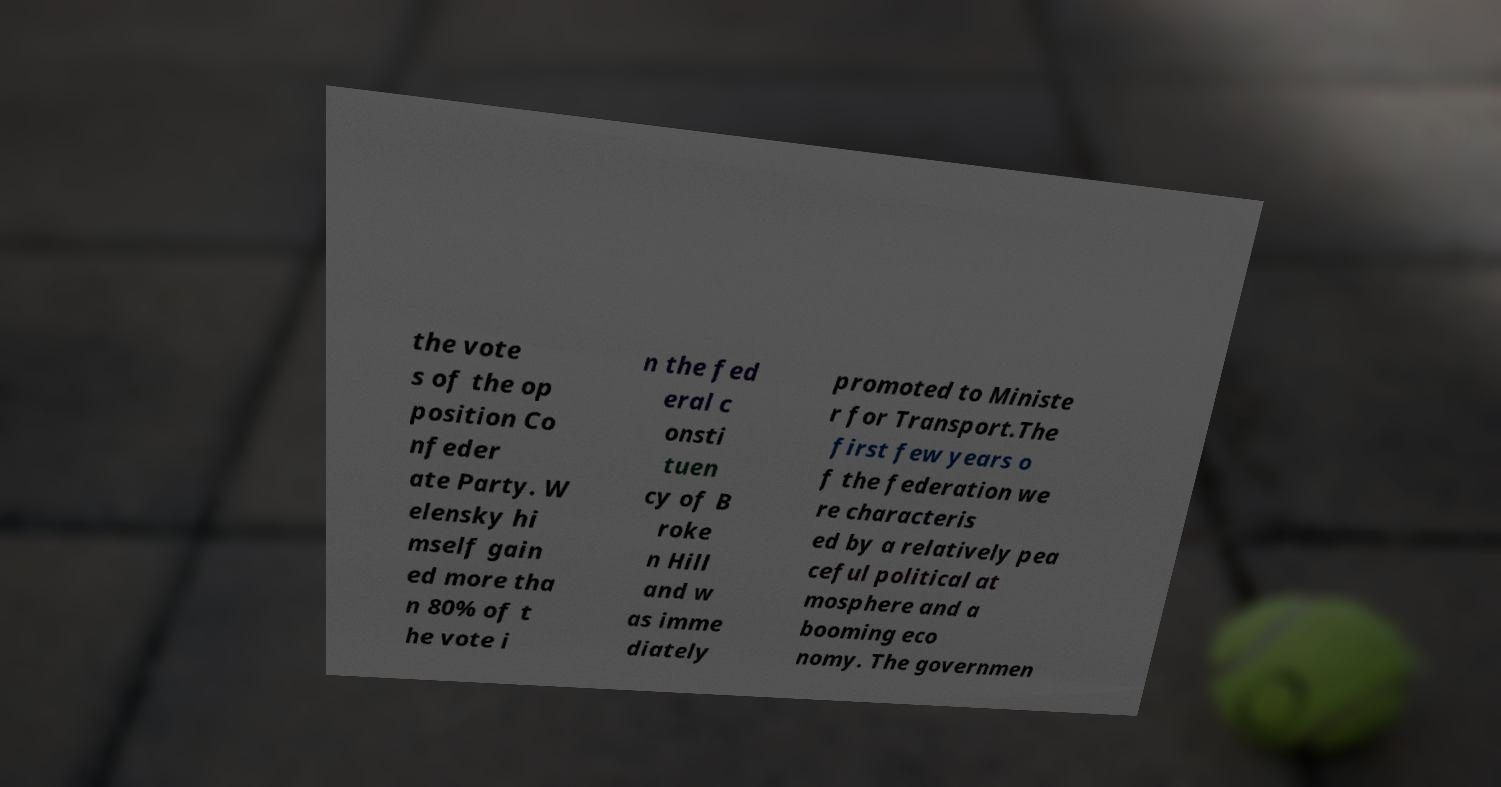For documentation purposes, I need the text within this image transcribed. Could you provide that? the vote s of the op position Co nfeder ate Party. W elensky hi mself gain ed more tha n 80% of t he vote i n the fed eral c onsti tuen cy of B roke n Hill and w as imme diately promoted to Ministe r for Transport.The first few years o f the federation we re characteris ed by a relatively pea ceful political at mosphere and a booming eco nomy. The governmen 